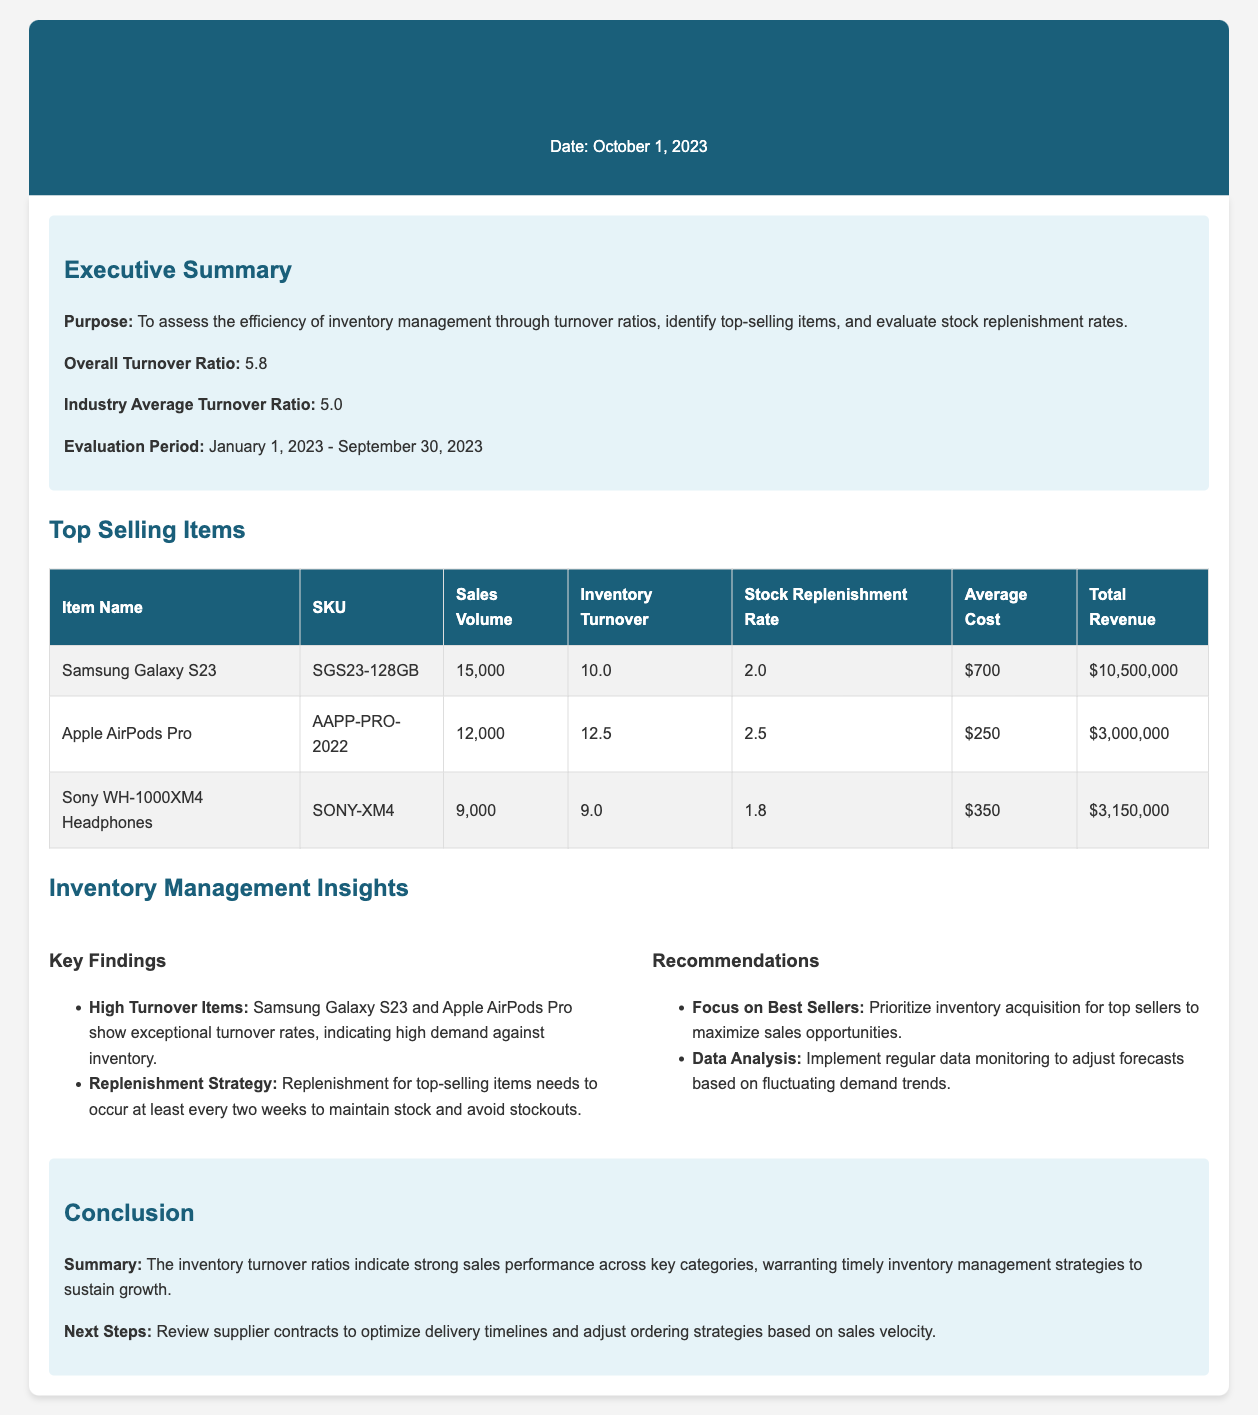What is the overall turnover ratio? The overall turnover ratio is a key performance metric highlighted in the report.
Answer: 5.8 What is the sales volume for the Samsung Galaxy S23? The sales volume for Samsung Galaxy S23 indicates the number of units sold and is specifically stated in the table.
Answer: 15,000 How often should stock replenishment occur for top-selling items? The report provides specific recommendations regarding stock replenishment frequency for top-selling items.
Answer: At least every two weeks What is the industry average turnover ratio? The industry average turnover ratio serves as a benchmark for comparing performance in the report.
Answer: 5.0 Which item has the highest inventory turnover? The inventory turnover indicates how rapidly inventory is sold and is found in the table under "Inventory Turnover".
Answer: Apple AirPods Pro What is the total revenue for the Sony WH-1000XM4 Headphones? The total revenue is calculated from the sales volume and average cost, which is explicitly listed in the table.
Answer: $3,150,000 What is a key finding related to high turnover items? The report summarizes specific patterns in inventory management regarding top-selling products.
Answer: Exceptional turnover rates What is the average cost of the Apple AirPods Pro? The average cost is specified in the table for each top-selling item listed.
Answer: $250 What is the conclusion regarding inventory management strategies? The conclusion summarizes the findings and suggests necessary actions for maintaining inventory effectively.
Answer: Timely inventory management strategies 